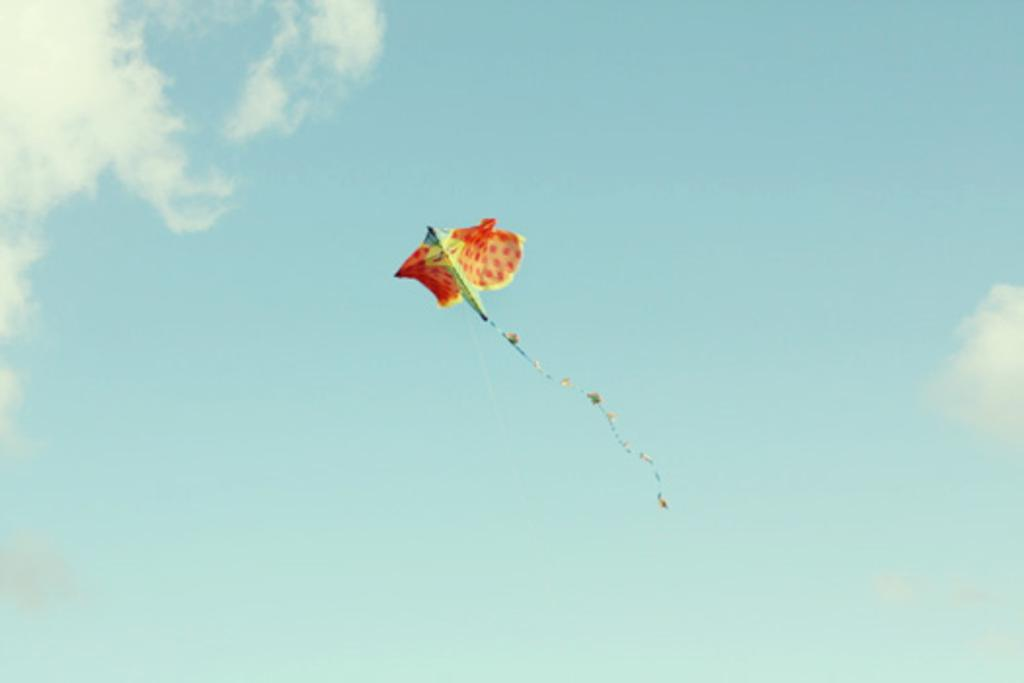Where was the picture taken? The picture was clicked outside. What can be seen in the sky in the image? There is a kite flying in the sky. What is visible in the background of the image? The sky is visible in the background of the image. What can be observed about the sky in the image? Clouds are present in the sky. What type of calculator is being used by the person holding the kite in the image? There is no person holding a kite or using a calculator in the image. How much sugar is present in the kite in the image? There is no sugar in the kite, as it is a flying object made of fabric or paper. 